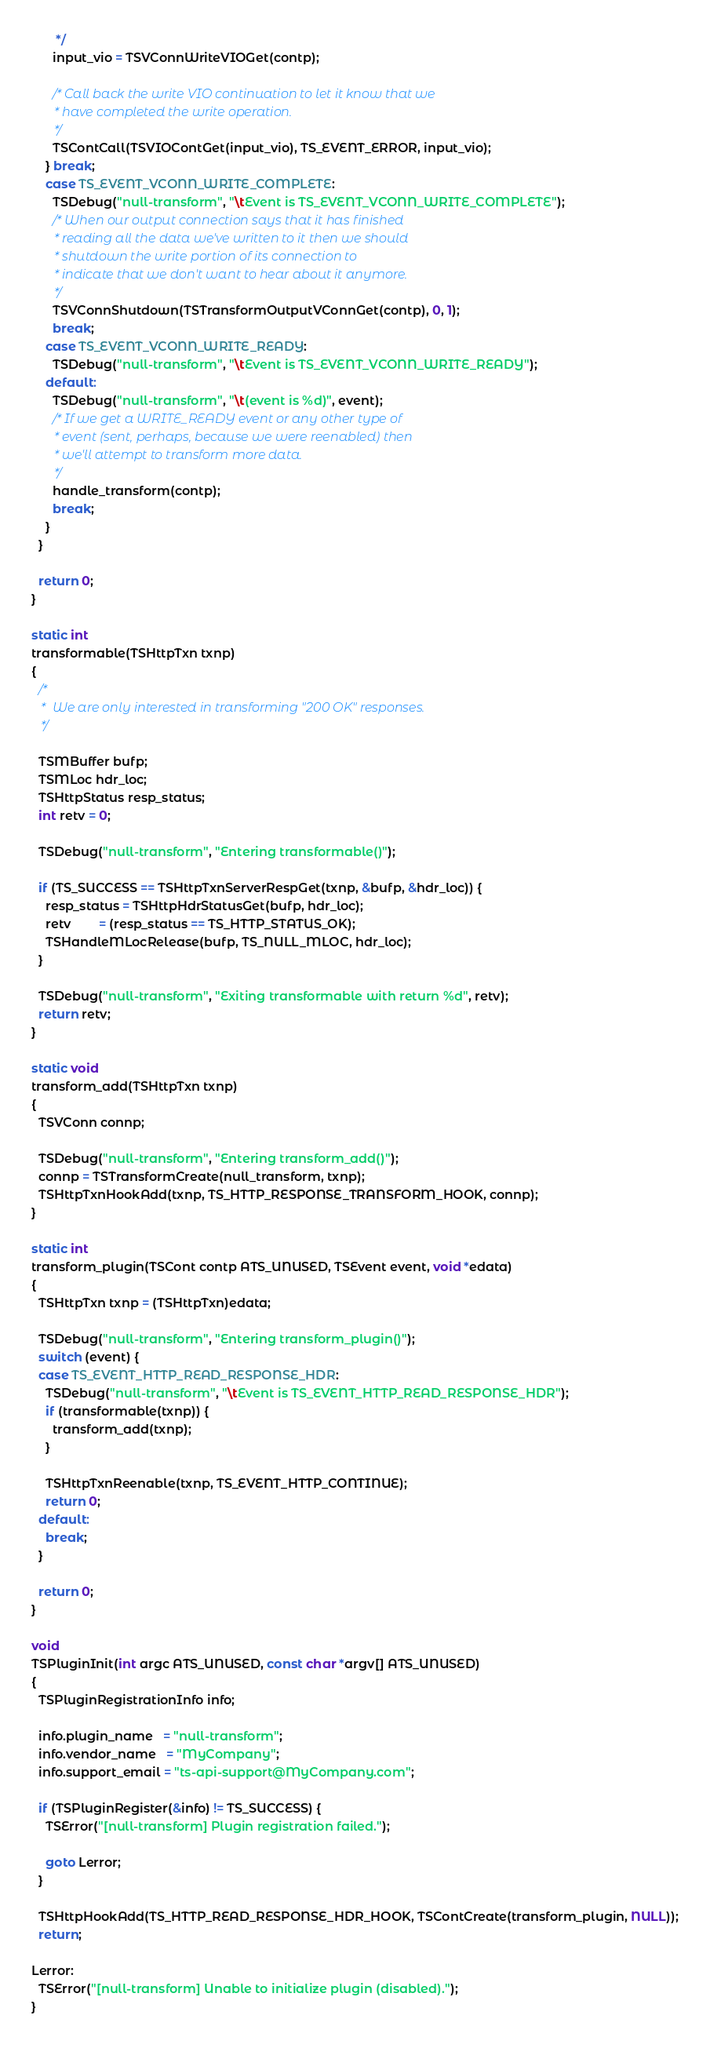Convert code to text. <code><loc_0><loc_0><loc_500><loc_500><_C_>       */
      input_vio = TSVConnWriteVIOGet(contp);

      /* Call back the write VIO continuation to let it know that we
       * have completed the write operation.
       */
      TSContCall(TSVIOContGet(input_vio), TS_EVENT_ERROR, input_vio);
    } break;
    case TS_EVENT_VCONN_WRITE_COMPLETE:
      TSDebug("null-transform", "\tEvent is TS_EVENT_VCONN_WRITE_COMPLETE");
      /* When our output connection says that it has finished
       * reading all the data we've written to it then we should
       * shutdown the write portion of its connection to
       * indicate that we don't want to hear about it anymore.
       */
      TSVConnShutdown(TSTransformOutputVConnGet(contp), 0, 1);
      break;
    case TS_EVENT_VCONN_WRITE_READY:
      TSDebug("null-transform", "\tEvent is TS_EVENT_VCONN_WRITE_READY");
    default:
      TSDebug("null-transform", "\t(event is %d)", event);
      /* If we get a WRITE_READY event or any other type of
       * event (sent, perhaps, because we were reenabled) then
       * we'll attempt to transform more data.
       */
      handle_transform(contp);
      break;
    }
  }

  return 0;
}

static int
transformable(TSHttpTxn txnp)
{
  /*
   *  We are only interested in transforming "200 OK" responses.
   */

  TSMBuffer bufp;
  TSMLoc hdr_loc;
  TSHttpStatus resp_status;
  int retv = 0;

  TSDebug("null-transform", "Entering transformable()");

  if (TS_SUCCESS == TSHttpTxnServerRespGet(txnp, &bufp, &hdr_loc)) {
    resp_status = TSHttpHdrStatusGet(bufp, hdr_loc);
    retv        = (resp_status == TS_HTTP_STATUS_OK);
    TSHandleMLocRelease(bufp, TS_NULL_MLOC, hdr_loc);
  }

  TSDebug("null-transform", "Exiting transformable with return %d", retv);
  return retv;
}

static void
transform_add(TSHttpTxn txnp)
{
  TSVConn connp;

  TSDebug("null-transform", "Entering transform_add()");
  connp = TSTransformCreate(null_transform, txnp);
  TSHttpTxnHookAdd(txnp, TS_HTTP_RESPONSE_TRANSFORM_HOOK, connp);
}

static int
transform_plugin(TSCont contp ATS_UNUSED, TSEvent event, void *edata)
{
  TSHttpTxn txnp = (TSHttpTxn)edata;

  TSDebug("null-transform", "Entering transform_plugin()");
  switch (event) {
  case TS_EVENT_HTTP_READ_RESPONSE_HDR:
    TSDebug("null-transform", "\tEvent is TS_EVENT_HTTP_READ_RESPONSE_HDR");
    if (transformable(txnp)) {
      transform_add(txnp);
    }

    TSHttpTxnReenable(txnp, TS_EVENT_HTTP_CONTINUE);
    return 0;
  default:
    break;
  }

  return 0;
}

void
TSPluginInit(int argc ATS_UNUSED, const char *argv[] ATS_UNUSED)
{
  TSPluginRegistrationInfo info;

  info.plugin_name   = "null-transform";
  info.vendor_name   = "MyCompany";
  info.support_email = "ts-api-support@MyCompany.com";

  if (TSPluginRegister(&info) != TS_SUCCESS) {
    TSError("[null-transform] Plugin registration failed.");

    goto Lerror;
  }

  TSHttpHookAdd(TS_HTTP_READ_RESPONSE_HDR_HOOK, TSContCreate(transform_plugin, NULL));
  return;

Lerror:
  TSError("[null-transform] Unable to initialize plugin (disabled).");
}
</code> 